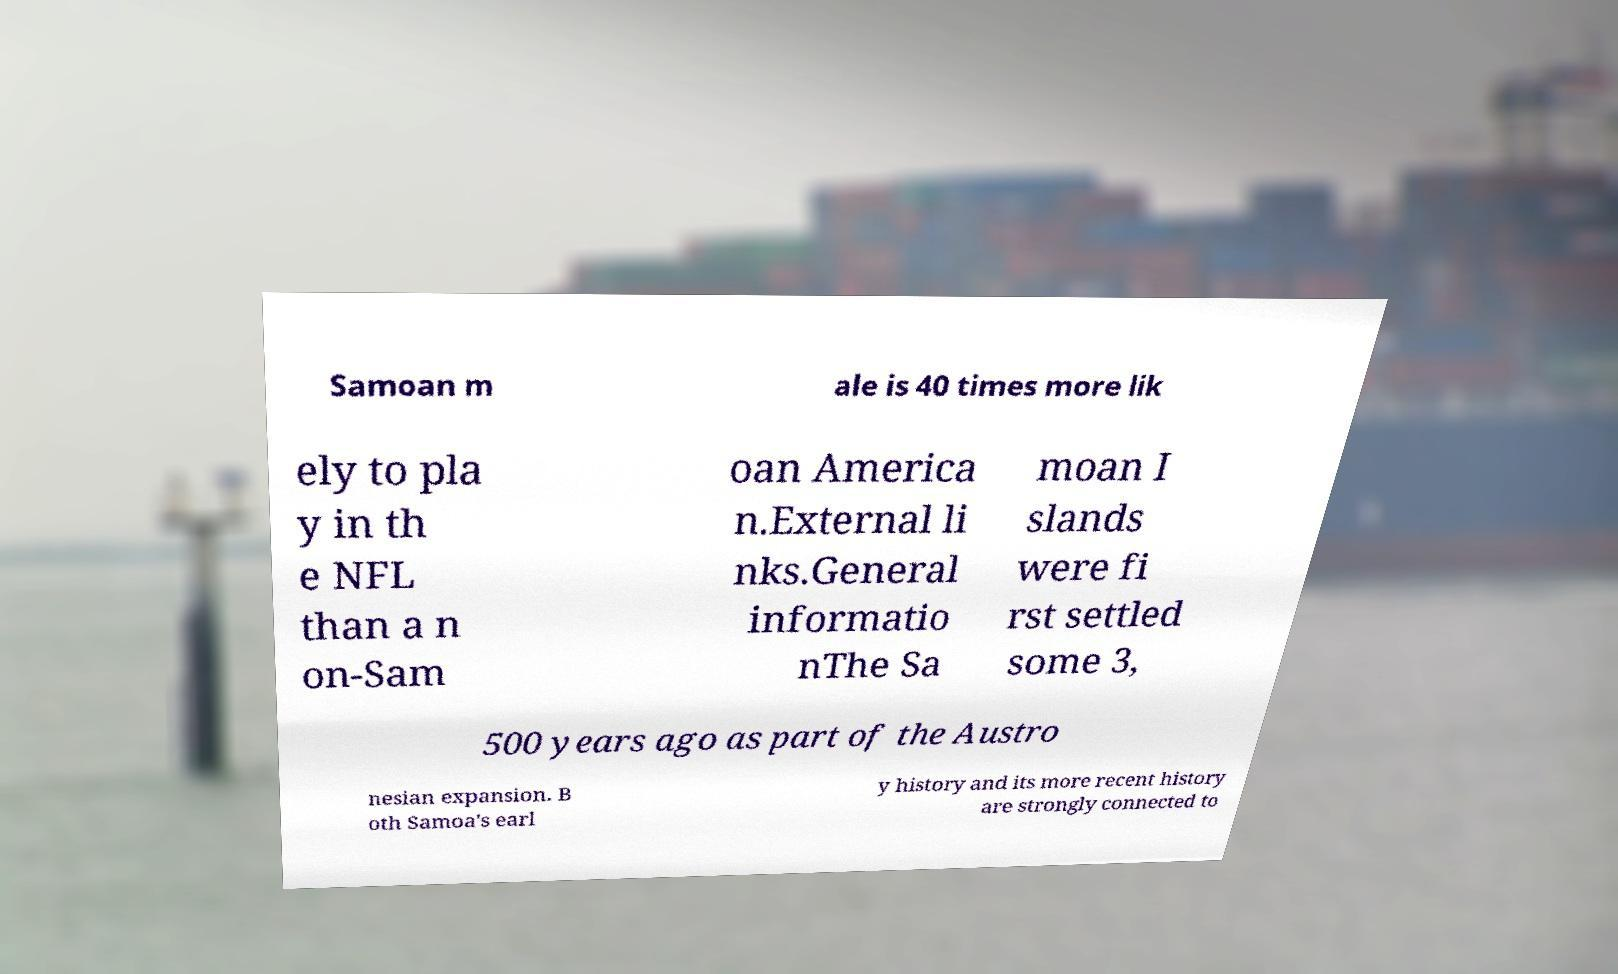Could you assist in decoding the text presented in this image and type it out clearly? Samoan m ale is 40 times more lik ely to pla y in th e NFL than a n on-Sam oan America n.External li nks.General informatio nThe Sa moan I slands were fi rst settled some 3, 500 years ago as part of the Austro nesian expansion. B oth Samoa's earl y history and its more recent history are strongly connected to 